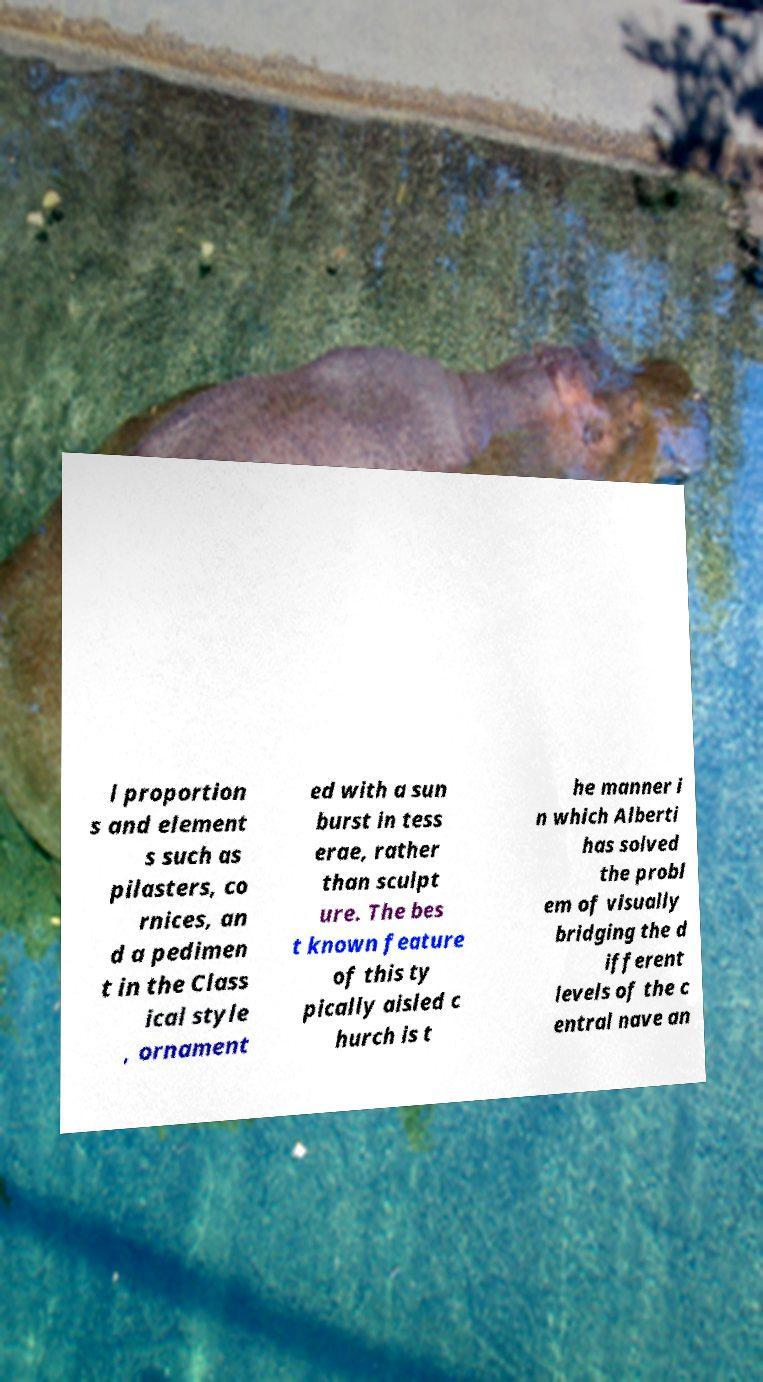There's text embedded in this image that I need extracted. Can you transcribe it verbatim? l proportion s and element s such as pilasters, co rnices, an d a pedimen t in the Class ical style , ornament ed with a sun burst in tess erae, rather than sculpt ure. The bes t known feature of this ty pically aisled c hurch is t he manner i n which Alberti has solved the probl em of visually bridging the d ifferent levels of the c entral nave an 